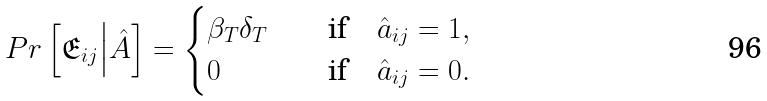<formula> <loc_0><loc_0><loc_500><loc_500>P r \left [ \mathfrak { E } _ { i j } \Big | \hat { A } \right ] = \begin{cases} \beta _ { T } \delta _ { T } \quad & \text {if} \quad \hat { a } _ { i j } = 1 , \\ 0 & \text {if} \quad \hat { a } _ { i j } = 0 . \end{cases}</formula> 